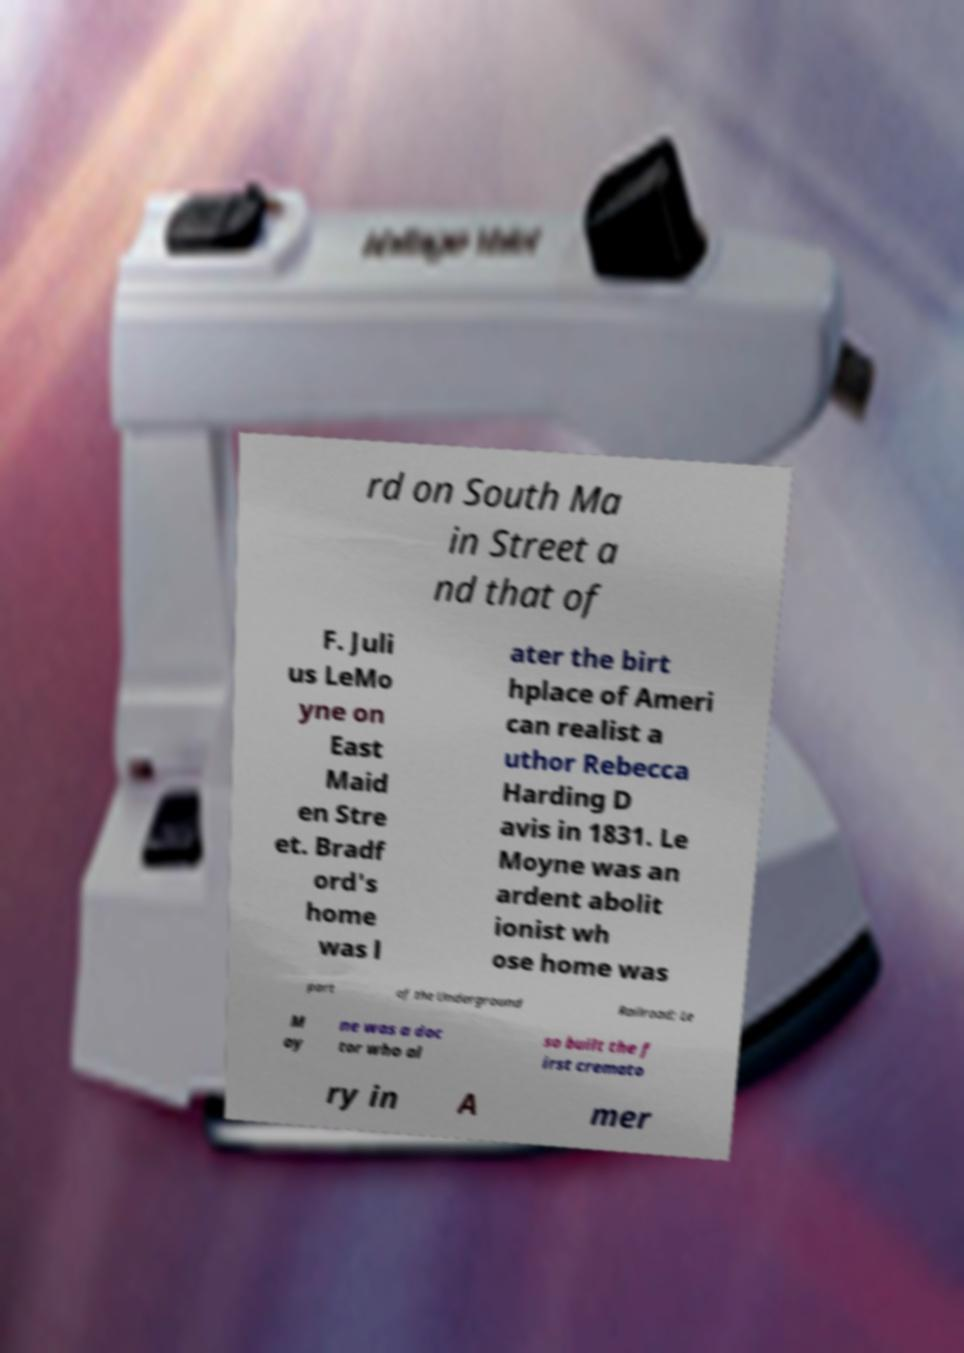Please identify and transcribe the text found in this image. rd on South Ma in Street a nd that of F. Juli us LeMo yne on East Maid en Stre et. Bradf ord's home was l ater the birt hplace of Ameri can realist a uthor Rebecca Harding D avis in 1831. Le Moyne was an ardent abolit ionist wh ose home was part of the Underground Railroad; Le M oy ne was a doc tor who al so built the f irst cremato ry in A mer 